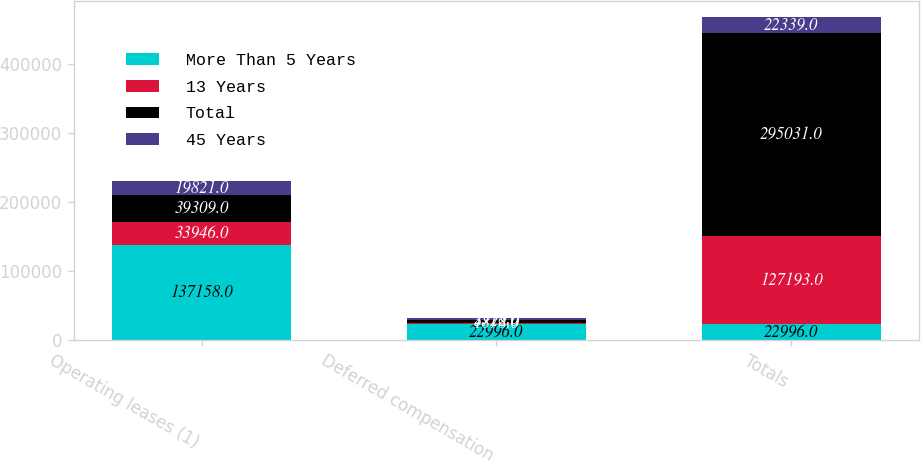Convert chart. <chart><loc_0><loc_0><loc_500><loc_500><stacked_bar_chart><ecel><fcel>Operating leases (1)<fcel>Deferred compensation<fcel>Totals<nl><fcel>More Than 5 Years<fcel>137158<fcel>22996<fcel>22996<nl><fcel>13 Years<fcel>33946<fcel>1878<fcel>127193<nl><fcel>Total<fcel>39309<fcel>3722<fcel>295031<nl><fcel>45 Years<fcel>19821<fcel>2518<fcel>22339<nl></chart> 